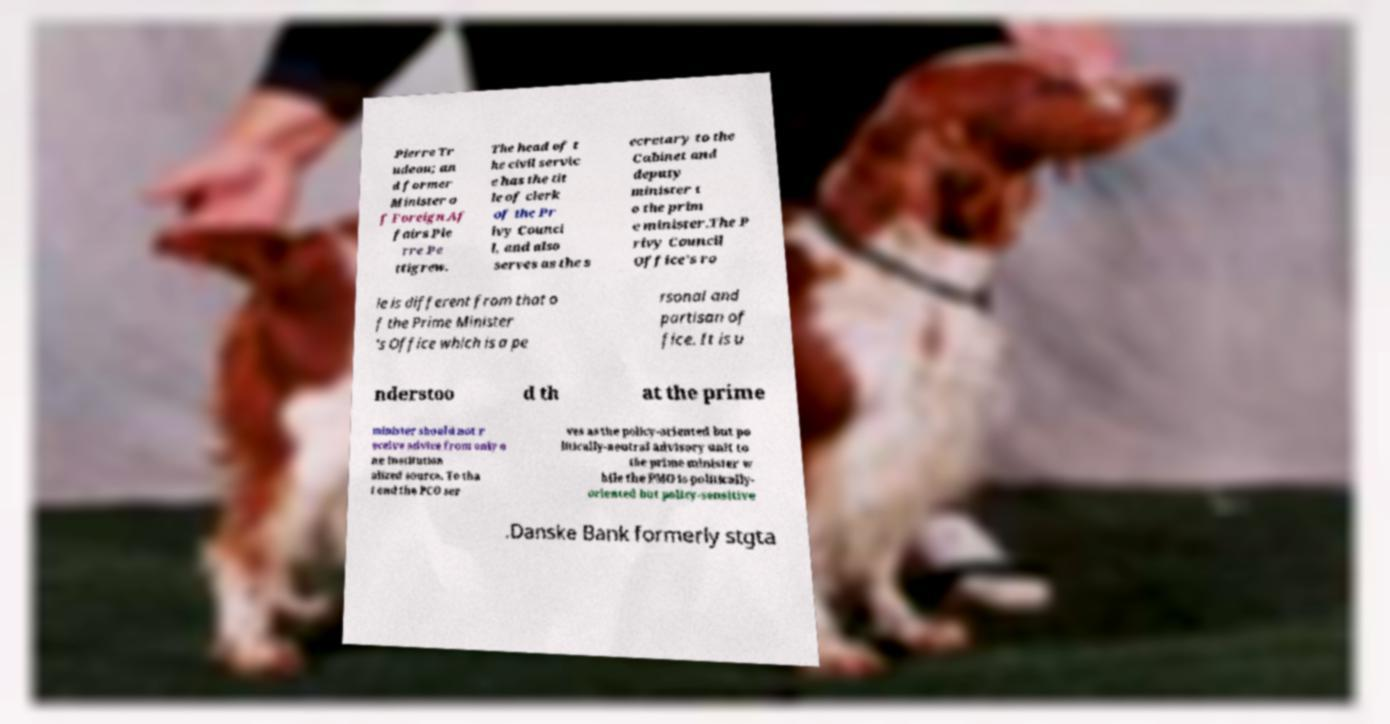Please read and relay the text visible in this image. What does it say? Pierre Tr udeau; an d former Minister o f Foreign Af fairs Pie rre Pe ttigrew. The head of t he civil servic e has the tit le of clerk of the Pr ivy Counci l, and also serves as the s ecretary to the Cabinet and deputy minister t o the prim e minister.The P rivy Council Office's ro le is different from that o f the Prime Minister 's Office which is a pe rsonal and partisan of fice. It is u nderstoo d th at the prime minister should not r eceive advice from only o ne institution alized source. To tha t end the PCO ser ves as the policy-oriented but po litically-neutral advisory unit to the prime minister w hile the PMO is politically- oriented but policy-sensitive .Danske Bank formerly stgta 